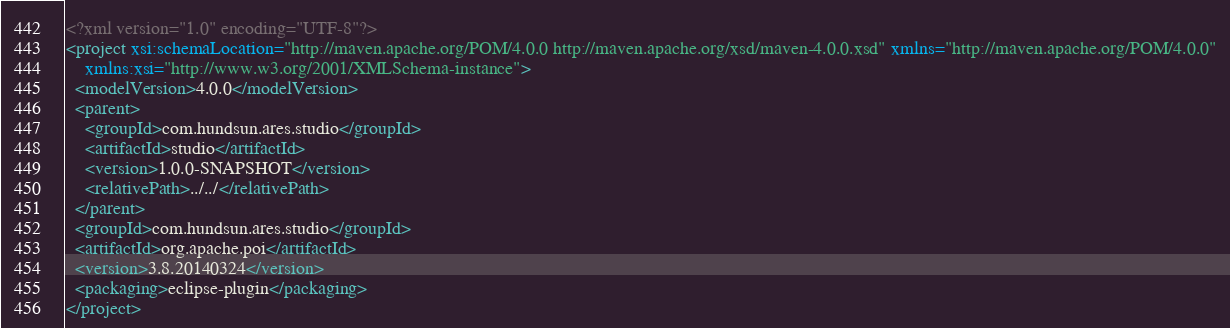Convert code to text. <code><loc_0><loc_0><loc_500><loc_500><_XML_><?xml version="1.0" encoding="UTF-8"?>
<project xsi:schemaLocation="http://maven.apache.org/POM/4.0.0 http://maven.apache.org/xsd/maven-4.0.0.xsd" xmlns="http://maven.apache.org/POM/4.0.0"
    xmlns:xsi="http://www.w3.org/2001/XMLSchema-instance">
  <modelVersion>4.0.0</modelVersion>
  <parent>
    <groupId>com.hundsun.ares.studio</groupId>
    <artifactId>studio</artifactId>
    <version>1.0.0-SNAPSHOT</version>
    <relativePath>../../</relativePath>
  </parent>
  <groupId>com.hundsun.ares.studio</groupId>
  <artifactId>org.apache.poi</artifactId>
  <version>3.8.20140324</version>
  <packaging>eclipse-plugin</packaging>
</project>
</code> 